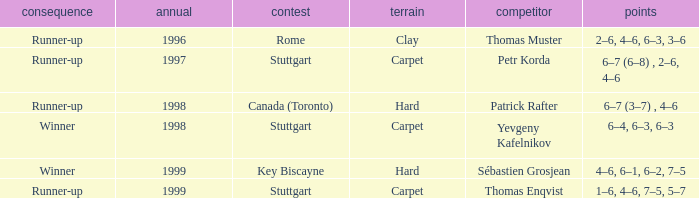What occurred as a consequence before 1997? Runner-up. 